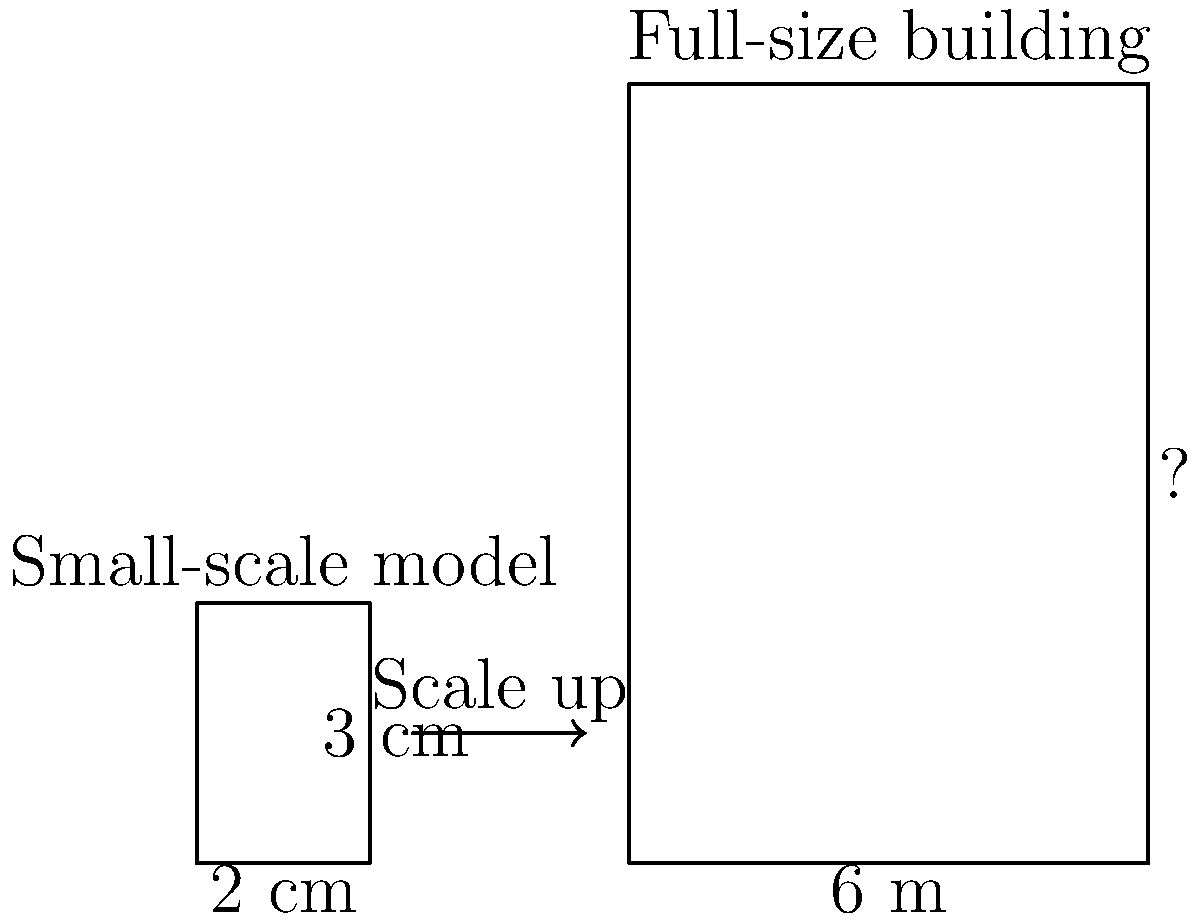A small-scale model of a building measures 2 cm wide and 3 cm tall. If the actual building is 6 meters wide, what is its height in meters? To solve this problem, we need to use the concept of scaling in transformational geometry. Here's a step-by-step approach:

1. Identify the scale factor:
   - Model width: 2 cm
   - Actual width: 6 m = 600 cm
   - Scale factor = 600 cm ÷ 2 cm = 300

2. Apply the scale factor to the height:
   - Model height: 3 cm
   - Actual height = 3 cm × 300 = 900 cm

3. Convert the result to meters:
   900 cm = 9 m

This approach demonstrates how scaling can be used to accurately determine full-size dimensions from a small-scale model, which is crucial in construction planning and design.
Answer: 9 meters 